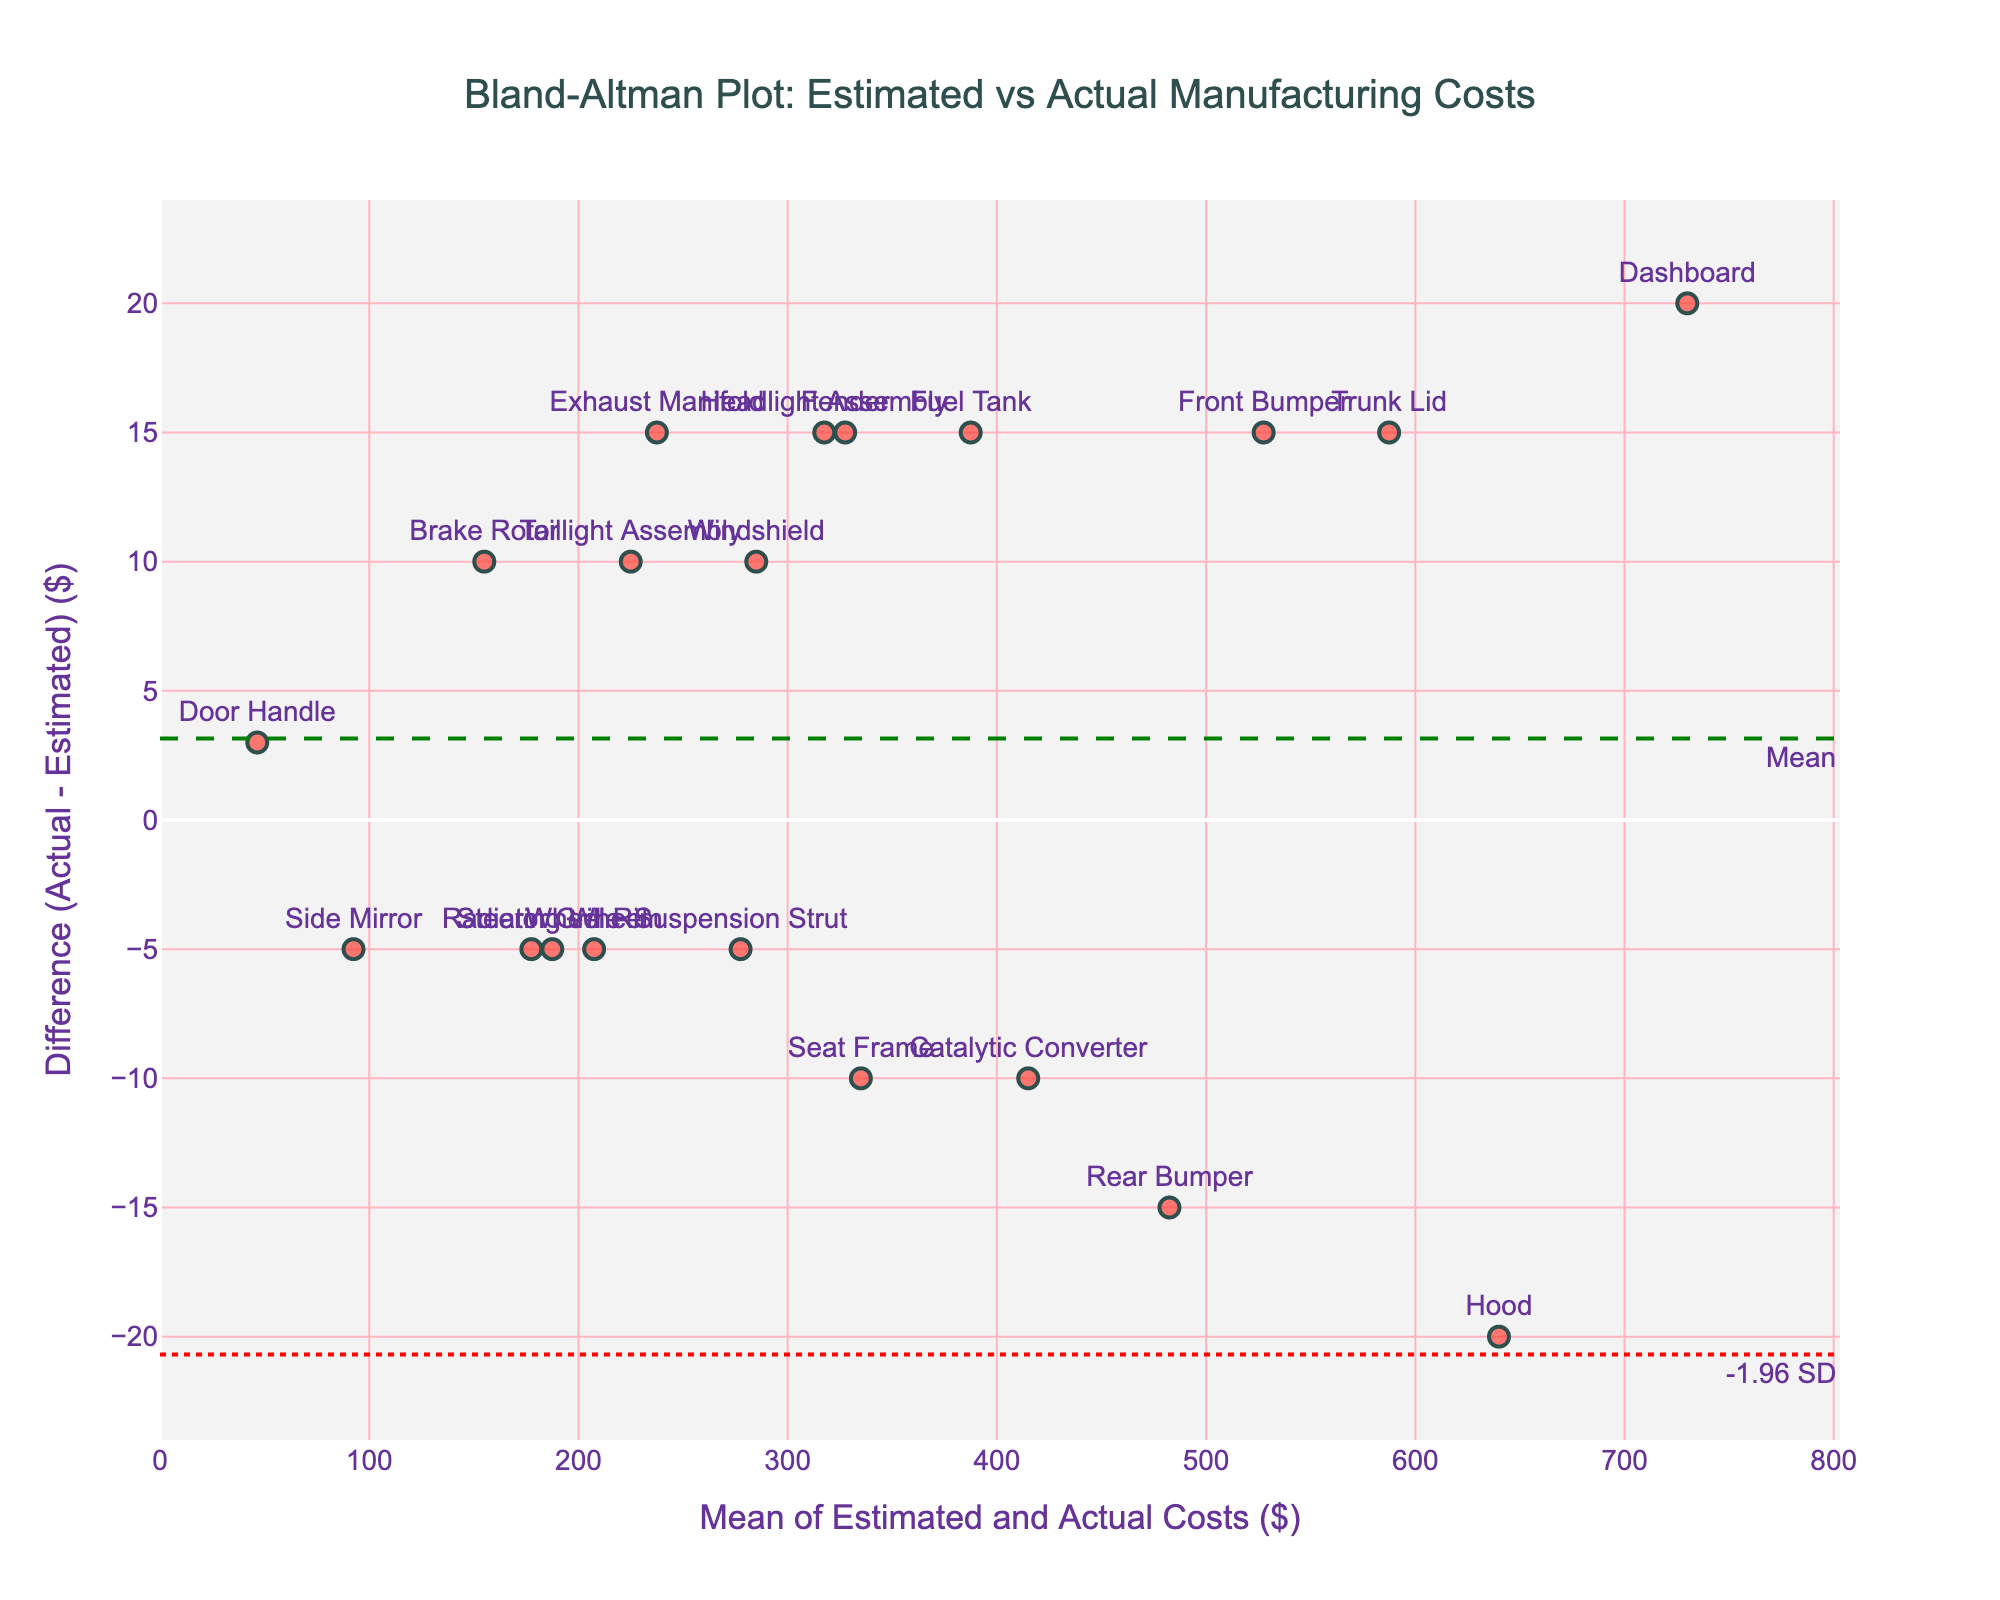what is the title of the figure? The title of the figure is prominently displayed at the top.
Answer: Bland-Altman Plot: Estimated vs Actual Manufacturing Costs What does the x-axis represent? The x-axis title is shown at the bottom of the plot. It indicates the variable represented on this axis.
Answer: Mean of Estimated and Actual Costs ($) What does the y-axis represent? The y-axis title is shown on the left side of the plot. It indicates the variable represented on this axis.
Answer: Difference (Actual - Estimated) ($) How many data points are on the plot? By counting the markers representing individual data points, we can determine the total number of data points.
Answer: 20 What is the average difference between the actual and estimated costs? The mean difference is indicated by a horizontal green dashed line on the plot.
Answer: -0.25 What are the limits of agreement on the plot? The limits of agreement are shown as red dotted lines, representing ±1.96 standard deviations from the mean difference. The annotations indicate these values.
Answer: Approximately -29.03 and 28.53 Which component has the largest positive difference between actual and estimated costs? By observing the placement of the data points, the component with the highest positive y-value represents the largest positive difference.
Answer: Trunk Lid Which component has the largest negative difference between actual and estimated costs? By observing the placement of the data points, the component with the lowest negative y-value represents the largest negative difference.
Answer: Front Bumper What is the range of the mean costs for the components? The range can be determined by observing the minimum and maximum x-values on the plot, which represent the mean of estimated and actual costs.
Answer: Approximately 67.5 to 730 Are there more components with actual costs higher than estimated or vice-versa? By observing which data points are above and below the horizontal line indicating a difference of zero, we can count and compare.
Answer: More components are above the zero line, indicating higher actual costs than estimated 